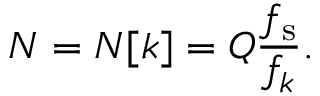<formula> <loc_0><loc_0><loc_500><loc_500>N = N [ k ] = Q { \frac { f _ { s } } { f _ { k } } } .</formula> 